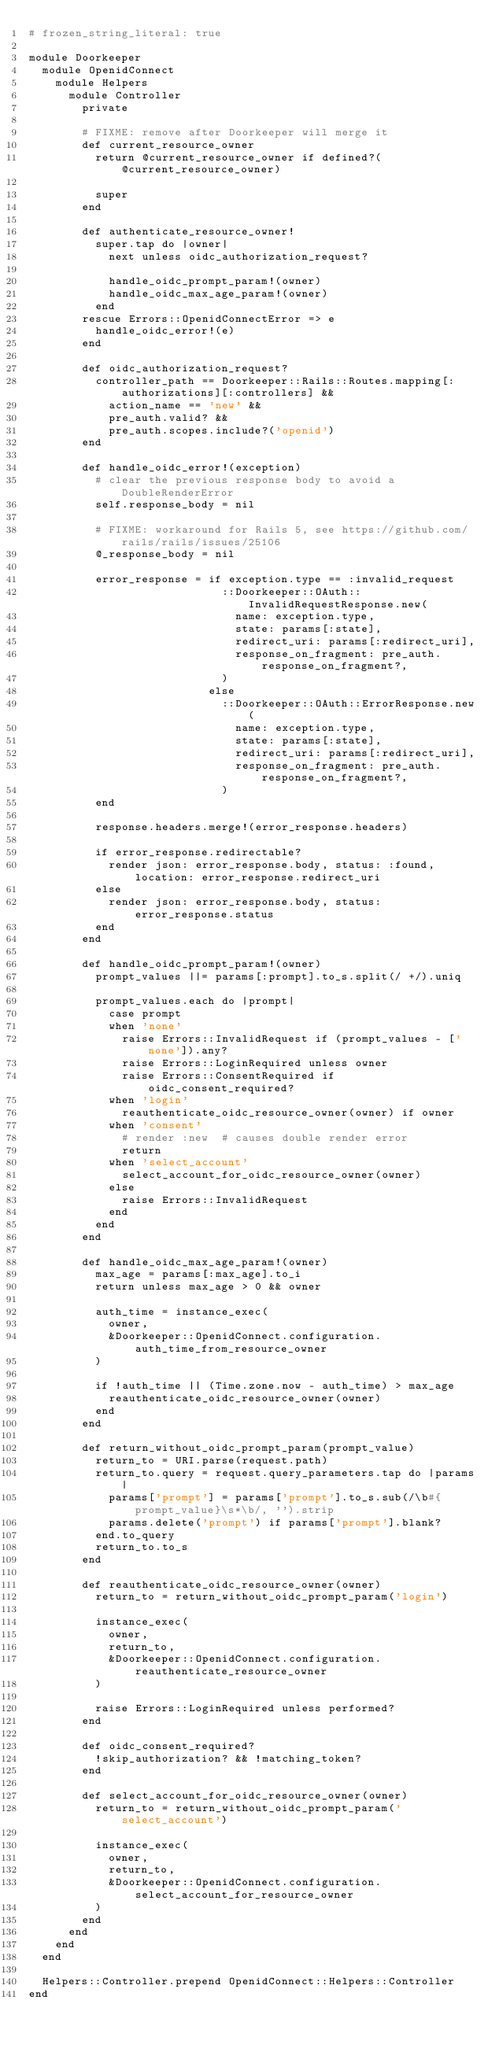<code> <loc_0><loc_0><loc_500><loc_500><_Ruby_># frozen_string_literal: true

module Doorkeeper
  module OpenidConnect
    module Helpers
      module Controller
        private

        # FIXME: remove after Doorkeeper will merge it
        def current_resource_owner
          return @current_resource_owner if defined?(@current_resource_owner)

          super
        end

        def authenticate_resource_owner!
          super.tap do |owner|
            next unless oidc_authorization_request?

            handle_oidc_prompt_param!(owner)
            handle_oidc_max_age_param!(owner)
          end
        rescue Errors::OpenidConnectError => e
          handle_oidc_error!(e)
        end

        def oidc_authorization_request?
          controller_path == Doorkeeper::Rails::Routes.mapping[:authorizations][:controllers] &&
            action_name == 'new' &&
            pre_auth.valid? &&
            pre_auth.scopes.include?('openid')
        end

        def handle_oidc_error!(exception)
          # clear the previous response body to avoid a DoubleRenderError
          self.response_body = nil

          # FIXME: workaround for Rails 5, see https://github.com/rails/rails/issues/25106
          @_response_body = nil

          error_response = if exception.type == :invalid_request
                             ::Doorkeeper::OAuth::InvalidRequestResponse.new(
                               name: exception.type,
                               state: params[:state],
                               redirect_uri: params[:redirect_uri],
                               response_on_fragment: pre_auth.response_on_fragment?,
                             )
                           else
                             ::Doorkeeper::OAuth::ErrorResponse.new(
                               name: exception.type,
                               state: params[:state],
                               redirect_uri: params[:redirect_uri],
                               response_on_fragment: pre_auth.response_on_fragment?,
                             )
          end

          response.headers.merge!(error_response.headers)

          if error_response.redirectable?
            render json: error_response.body, status: :found, location: error_response.redirect_uri
          else
            render json: error_response.body, status: error_response.status
          end
        end

        def handle_oidc_prompt_param!(owner)
          prompt_values ||= params[:prompt].to_s.split(/ +/).uniq

          prompt_values.each do |prompt|
            case prompt
            when 'none'
              raise Errors::InvalidRequest if (prompt_values - ['none']).any?
              raise Errors::LoginRequired unless owner
              raise Errors::ConsentRequired if oidc_consent_required?
            when 'login'
              reauthenticate_oidc_resource_owner(owner) if owner
            when 'consent'
              # render :new  # causes double render error
              return
            when 'select_account'
              select_account_for_oidc_resource_owner(owner)
            else
              raise Errors::InvalidRequest
            end
          end
        end

        def handle_oidc_max_age_param!(owner)
          max_age = params[:max_age].to_i
          return unless max_age > 0 && owner

          auth_time = instance_exec(
            owner,
            &Doorkeeper::OpenidConnect.configuration.auth_time_from_resource_owner
          )

          if !auth_time || (Time.zone.now - auth_time) > max_age
            reauthenticate_oidc_resource_owner(owner)
          end
        end

        def return_without_oidc_prompt_param(prompt_value)
          return_to = URI.parse(request.path)
          return_to.query = request.query_parameters.tap do |params|
            params['prompt'] = params['prompt'].to_s.sub(/\b#{prompt_value}\s*\b/, '').strip
            params.delete('prompt') if params['prompt'].blank?
          end.to_query
          return_to.to_s
        end

        def reauthenticate_oidc_resource_owner(owner)
          return_to = return_without_oidc_prompt_param('login')

          instance_exec(
            owner,
            return_to,
            &Doorkeeper::OpenidConnect.configuration.reauthenticate_resource_owner
          )

          raise Errors::LoginRequired unless performed?
        end

        def oidc_consent_required?
          !skip_authorization? && !matching_token?
        end

        def select_account_for_oidc_resource_owner(owner)
          return_to = return_without_oidc_prompt_param('select_account')

          instance_exec(
            owner,
            return_to,
            &Doorkeeper::OpenidConnect.configuration.select_account_for_resource_owner
          )
        end
      end
    end
  end

  Helpers::Controller.prepend OpenidConnect::Helpers::Controller
end
</code> 